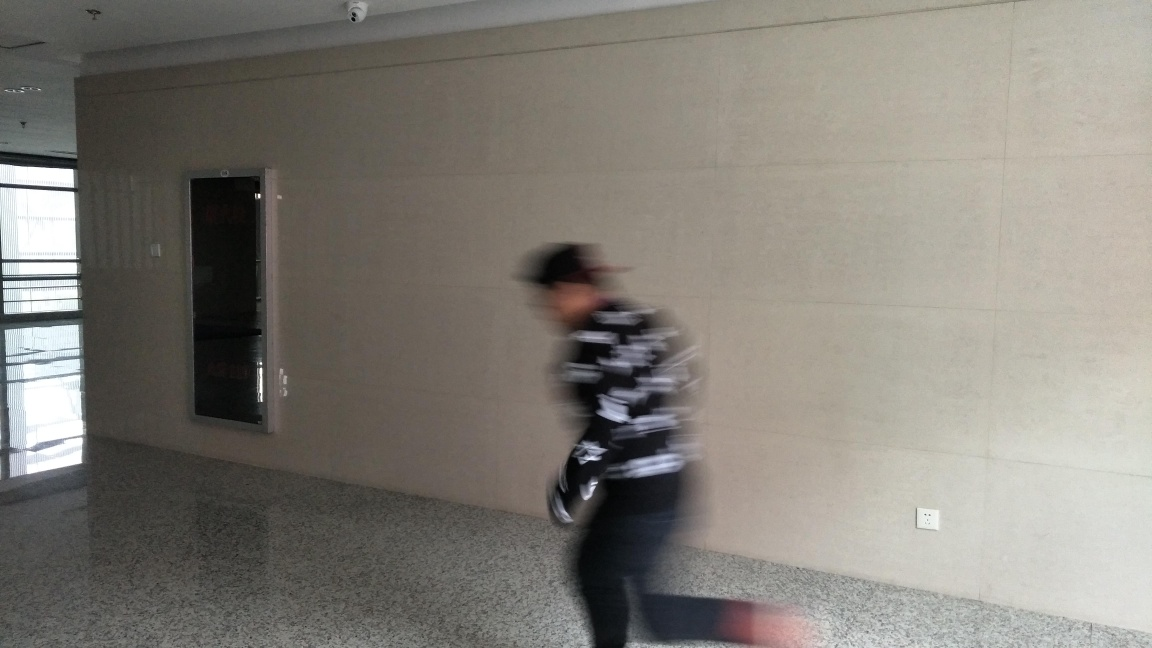What is the condition of the details? The details in the image are hard to discern due to motion blur, particularly affecting the person, who appears to be moving quickly through the space. This creates a dynamic but unclear scene with limited visibility of finer details. 